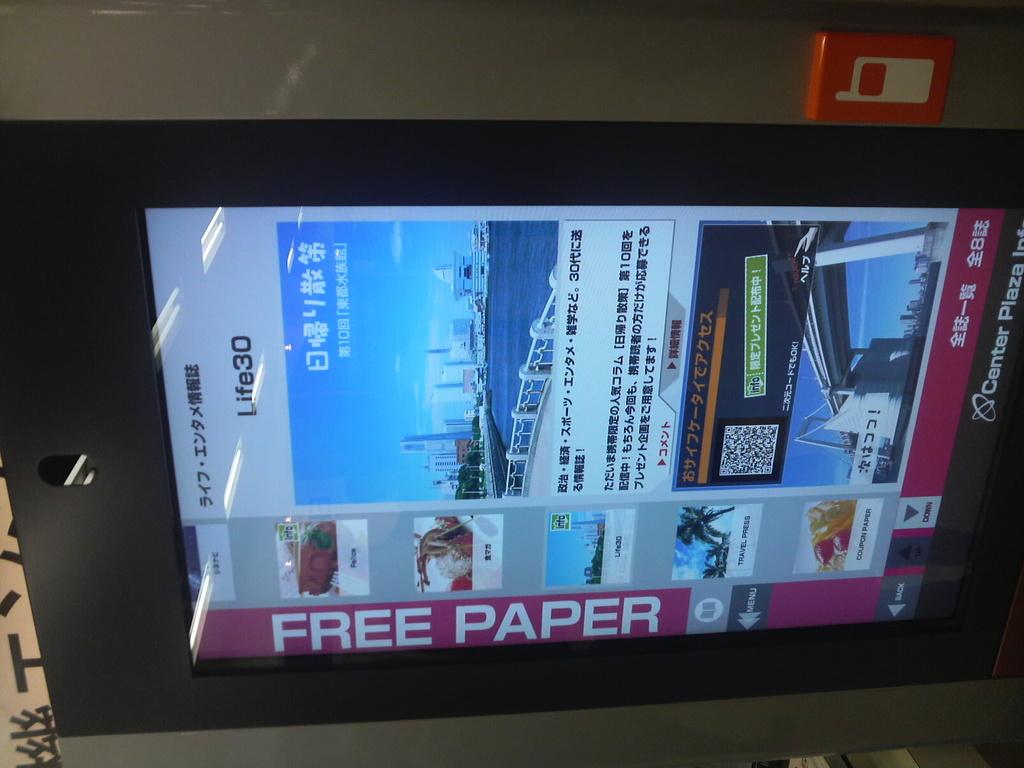Where can i get the free paper?
Provide a succinct answer. Center plaza. What's the title of the paper?
Ensure brevity in your answer.  Life30. 